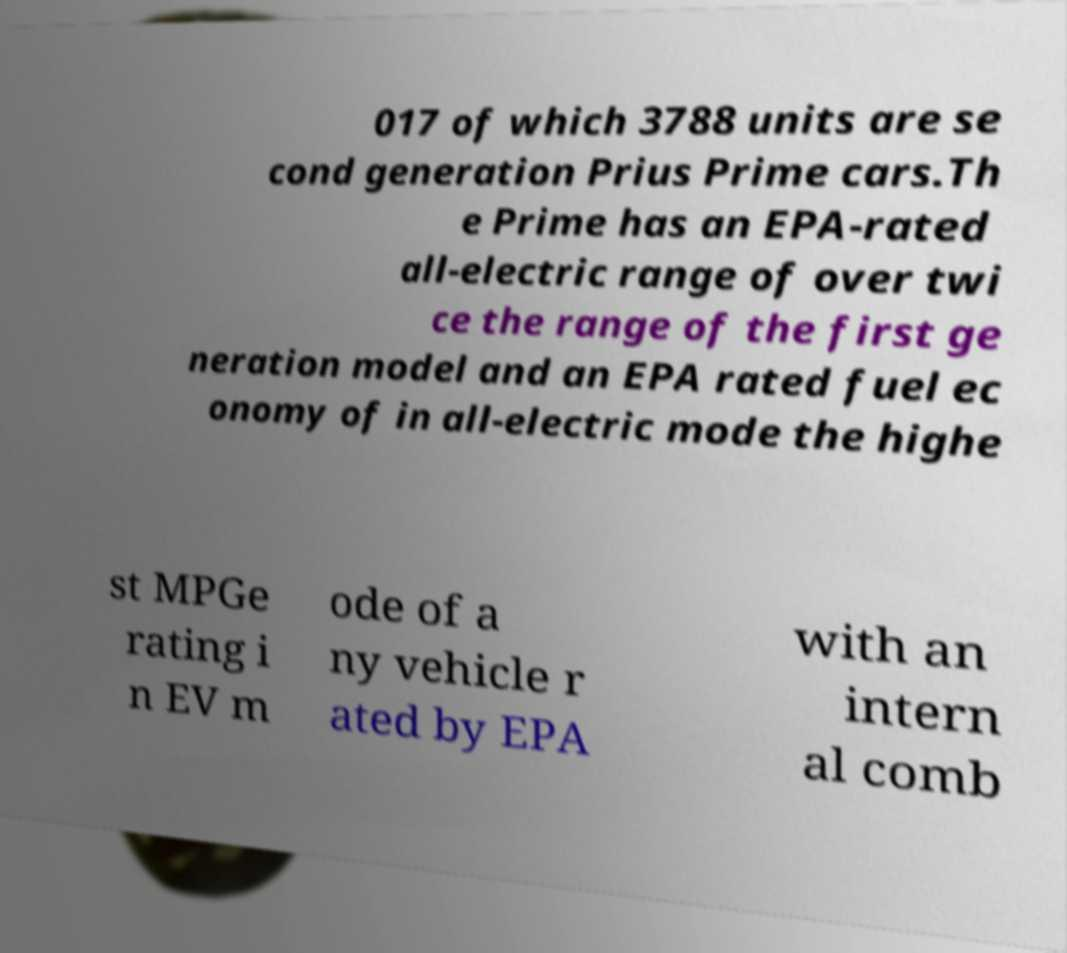What messages or text are displayed in this image? I need them in a readable, typed format. 017 of which 3788 units are se cond generation Prius Prime cars.Th e Prime has an EPA-rated all-electric range of over twi ce the range of the first ge neration model and an EPA rated fuel ec onomy of in all-electric mode the highe st MPGe rating i n EV m ode of a ny vehicle r ated by EPA with an intern al comb 